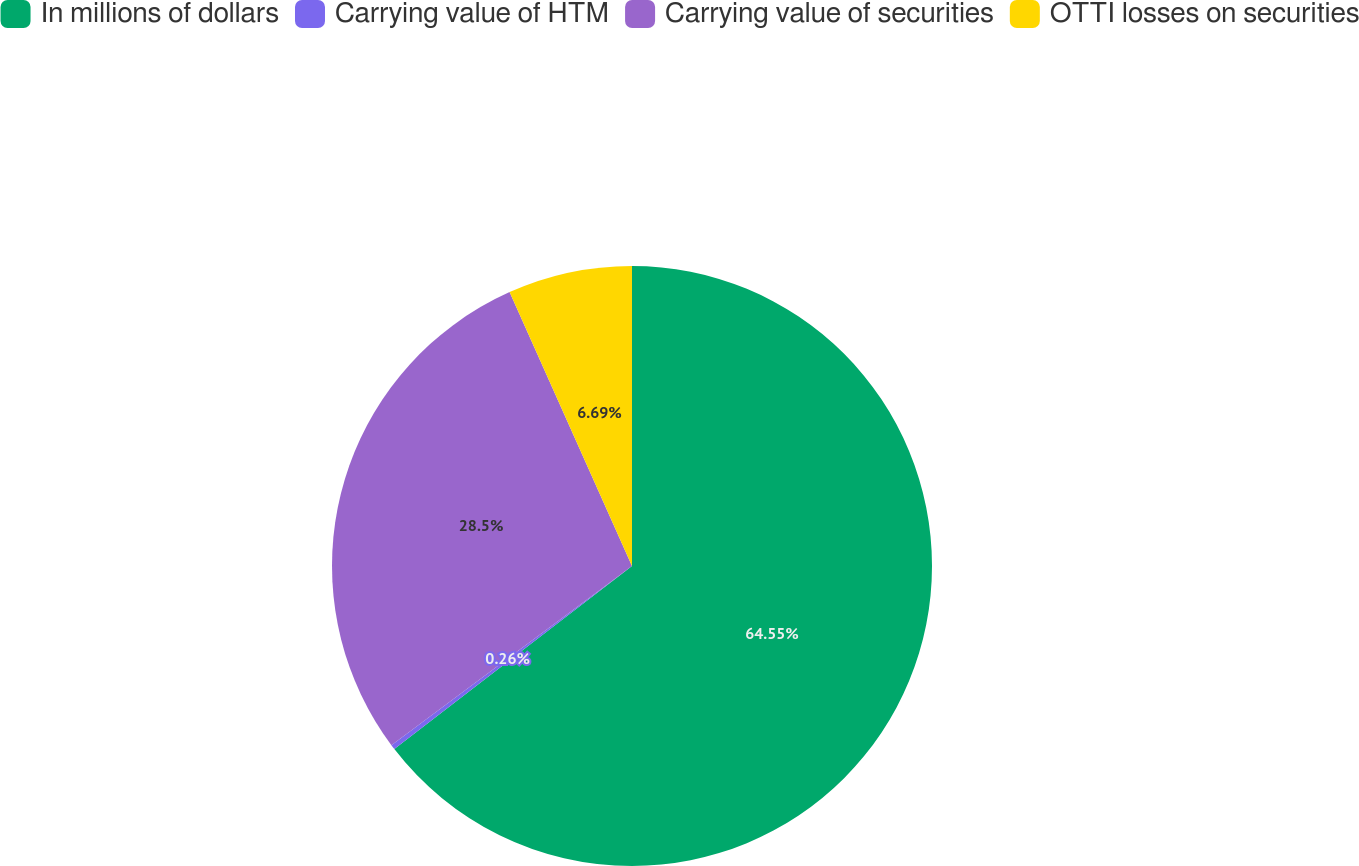<chart> <loc_0><loc_0><loc_500><loc_500><pie_chart><fcel>In millions of dollars<fcel>Carrying value of HTM<fcel>Carrying value of securities<fcel>OTTI losses on securities<nl><fcel>64.56%<fcel>0.26%<fcel>28.5%<fcel>6.69%<nl></chart> 